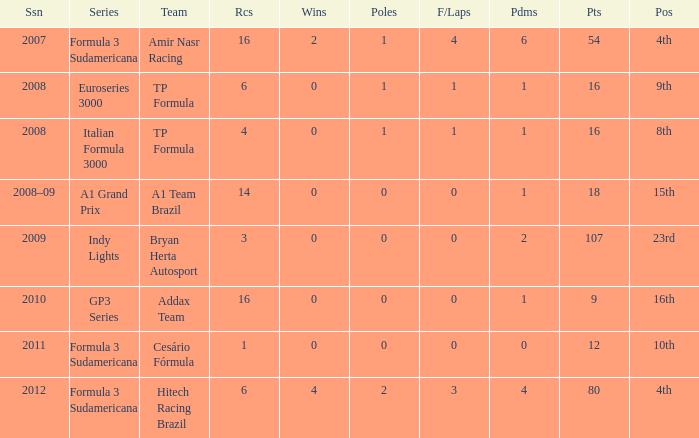How many points did he win in the race with more than 1.0 poles? 80.0. 